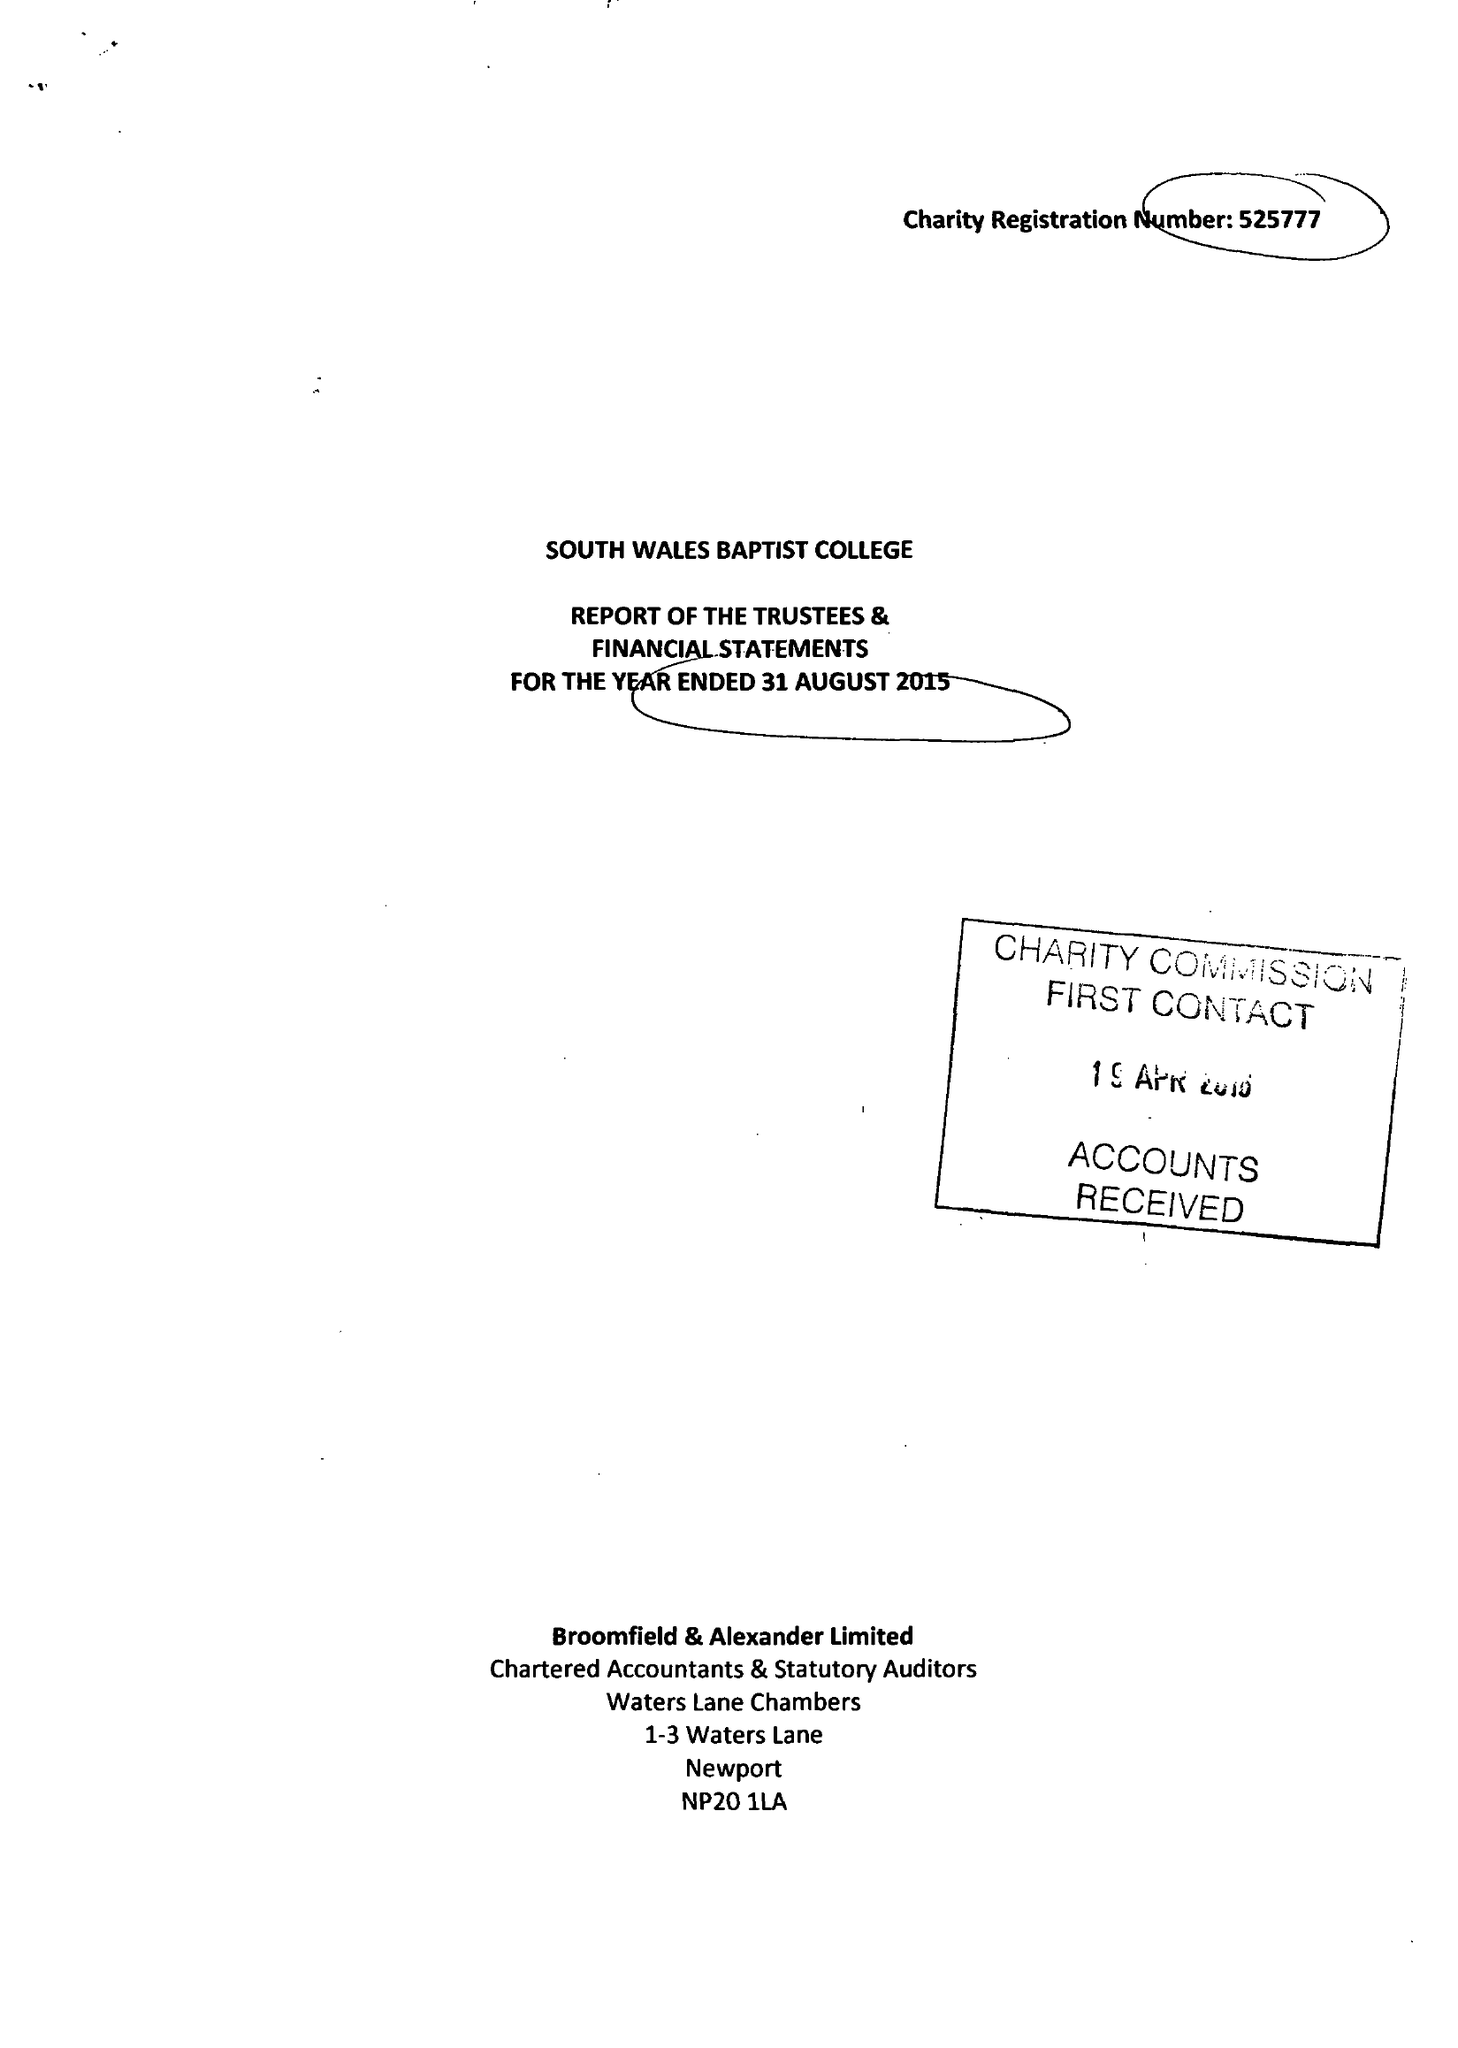What is the value for the charity_name?
Answer the question using a single word or phrase. South Wales Baptist College 